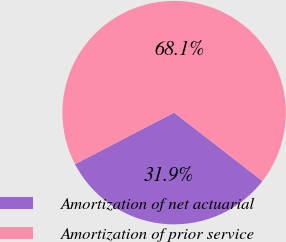Convert chart. <chart><loc_0><loc_0><loc_500><loc_500><pie_chart><fcel>Amortization of net actuarial<fcel>Amortization of prior service<nl><fcel>31.89%<fcel>68.11%<nl></chart> 